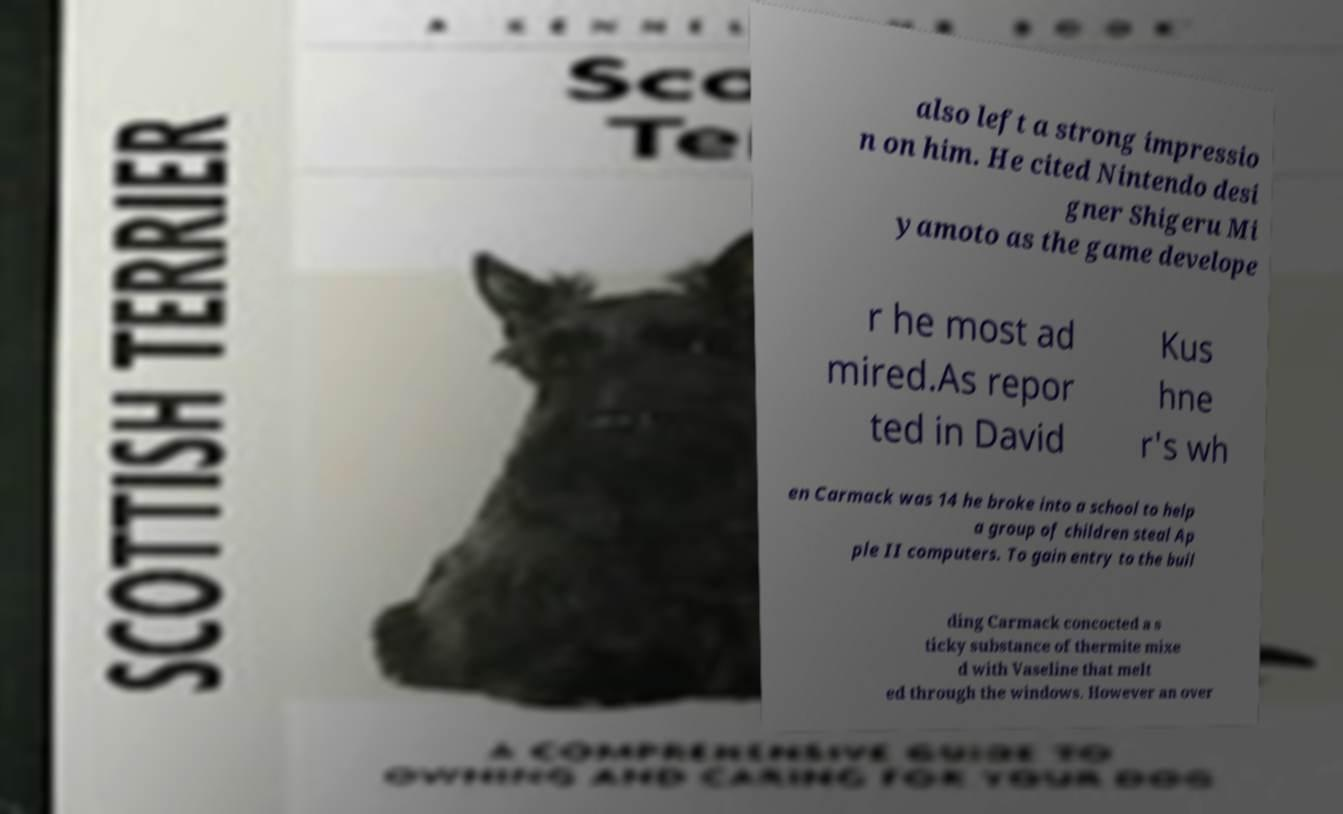Could you extract and type out the text from this image? also left a strong impressio n on him. He cited Nintendo desi gner Shigeru Mi yamoto as the game develope r he most ad mired.As repor ted in David Kus hne r's wh en Carmack was 14 he broke into a school to help a group of children steal Ap ple II computers. To gain entry to the buil ding Carmack concocted a s ticky substance of thermite mixe d with Vaseline that melt ed through the windows. However an over 